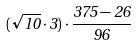<formula> <loc_0><loc_0><loc_500><loc_500>( \sqrt { 1 0 } \cdot 3 ) \cdot \frac { 3 7 5 - 2 6 } { 9 6 }</formula> 